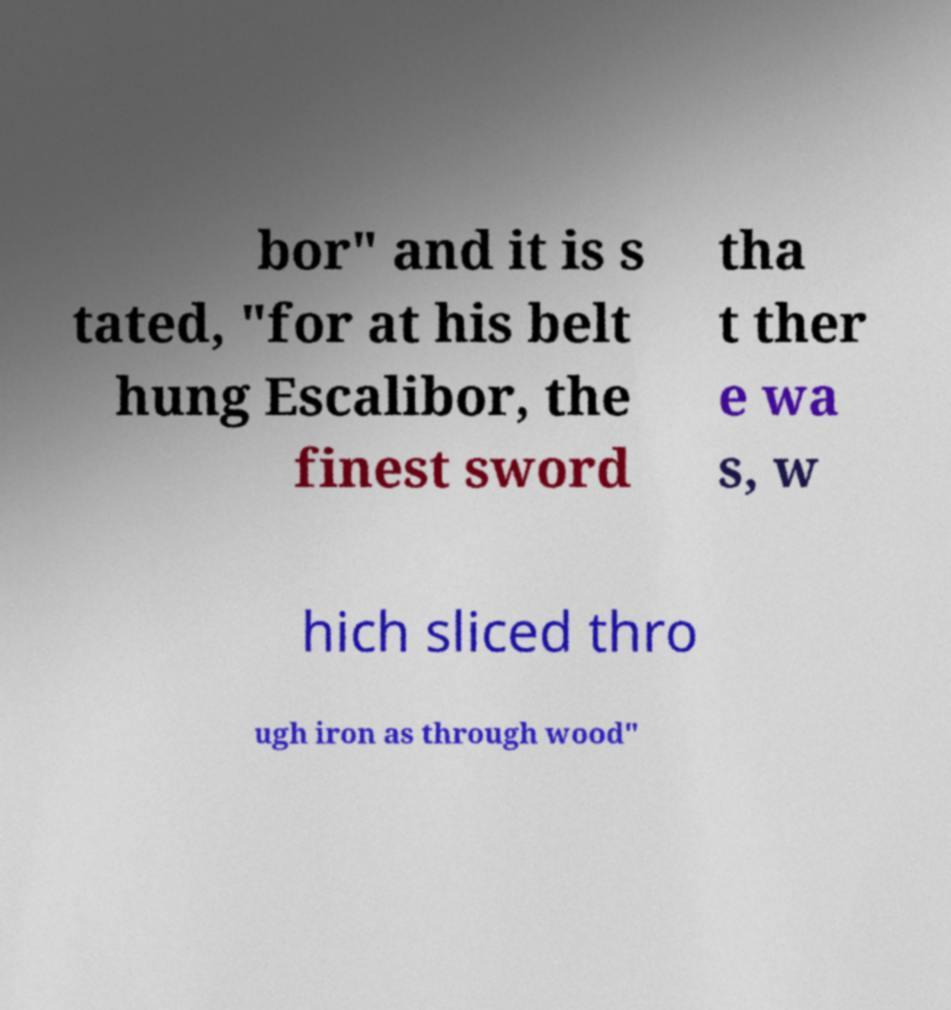Can you read and provide the text displayed in the image?This photo seems to have some interesting text. Can you extract and type it out for me? bor" and it is s tated, "for at his belt hung Escalibor, the finest sword tha t ther e wa s, w hich sliced thro ugh iron as through wood" 